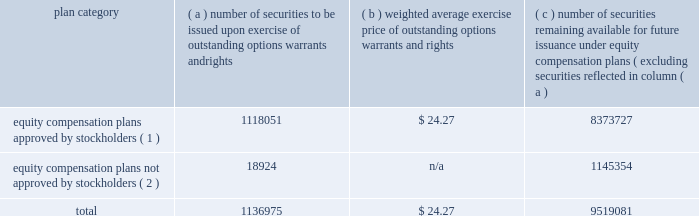Dividends and distributions we pay regular quarterly dividends to holders of our common stock .
On february 16 , 2007 , our board of directors declared the first quarterly installment of our 2007 dividend in the amount of $ 0.475 per share , payable on march 30 , 2007 to stockholders of record on march 20 , 2007 .
We expect to distribute 100% ( 100 % ) or more of our taxable net income to our stockholders for 2007 .
Our board of directors normally makes decisions regarding the frequency and amount of our dividends on a quarterly basis .
Because the board considers a number of factors when making these decisions , we cannot assure you that we will maintain the policy stated above .
Please see 201ccautionary statements 201d and the risk factors included in part i , item 1a of this annual report on form 10-k for a description of other factors that may affect our distribution policy .
Our stockholders may reinvest all or a portion of any cash distribution on their shares of our common stock by participating in our distribution reinvestment and stock purchase plan , subject to the terms of the plan .
See 201cnote 15 2014capital stock 201d of the notes to consolidated financial statements included in item 8 of this annual report on form 10-k .
Director and employee stock sales certain of our directors , executive officers and other employees have adopted and may , from time to time in the future , adopt non-discretionary , written trading plans that comply with rule 10b5-1 under the exchange act , or otherwise monetize their equity-based compensation .
Securities authorized for issuance under equity compensation plans the table summarizes information with respect to our equity compensation plans as of december 31 , 2006 : plan category number of securities to be issued upon exercise of outstanding options , warrants and rights weighted average exercise price of outstanding options , warrants and rights number of securities remaining available for future issuance under equity compensation plans ( excluding securities reflected in column ( a ) equity compensation plans approved by stockholders ( 1 ) .
1118051 $ 24.27 8373727 equity compensation plans not approved by stockholders ( 2 ) .
18924 n/a 1145354 .
( 1 ) these plans consist of ( i ) the 1987 incentive compensation program ( employee plan ) ; ( ii ) the theratx , incorporated 1996 stock option/stock issuance plan ; ( iii ) the 2000 incentive compensation plan ( employee plan ) ( formerly known as the 1997 incentive compensation plan ) ; ( iv ) the 2004 stock plan for directors ( which amended and restated the 2000 stock option plan for directors ( formerly known as the 1997 stock option plan for non-employee directors ) ) ; ( v ) the employee and director stock purchase plan ; ( vi ) the 2006 incentive plan ; and ( vii ) the 2006 stock plan for directors .
( 2 ) these plans consist of ( i ) the common stock purchase plan for directors , under which our non-employee directors may receive common stock in lieu of directors 2019 fees , ( ii ) the nonemployee director deferred stock compensation plan , under which our non-employee directors may receive units convertible on a one-for-one basis into common stock in lieu of director fees , and ( iii ) the executive deferred stock compensation plan , under which our executive officers may receive units convertible on a one-for-one basis into common stock in lieu of compensation. .
What is the total equity compensation plans approved by stockholders as of december 312006? 
Rationale: the total equity compensation plans approved by stockholders is the sum of the approved amount and remaining available for future issuance under equity compensation plans
Computations: (1118051 + 8373727)
Answer: 9491778.0. Dividends and distributions we pay regular quarterly dividends to holders of our common stock .
On february 16 , 2007 , our board of directors declared the first quarterly installment of our 2007 dividend in the amount of $ 0.475 per share , payable on march 30 , 2007 to stockholders of record on march 20 , 2007 .
We expect to distribute 100% ( 100 % ) or more of our taxable net income to our stockholders for 2007 .
Our board of directors normally makes decisions regarding the frequency and amount of our dividends on a quarterly basis .
Because the board considers a number of factors when making these decisions , we cannot assure you that we will maintain the policy stated above .
Please see 201ccautionary statements 201d and the risk factors included in part i , item 1a of this annual report on form 10-k for a description of other factors that may affect our distribution policy .
Our stockholders may reinvest all or a portion of any cash distribution on their shares of our common stock by participating in our distribution reinvestment and stock purchase plan , subject to the terms of the plan .
See 201cnote 15 2014capital stock 201d of the notes to consolidated financial statements included in item 8 of this annual report on form 10-k .
Director and employee stock sales certain of our directors , executive officers and other employees have adopted and may , from time to time in the future , adopt non-discretionary , written trading plans that comply with rule 10b5-1 under the exchange act , or otherwise monetize their equity-based compensation .
Securities authorized for issuance under equity compensation plans the table summarizes information with respect to our equity compensation plans as of december 31 , 2006 : plan category number of securities to be issued upon exercise of outstanding options , warrants and rights weighted average exercise price of outstanding options , warrants and rights number of securities remaining available for future issuance under equity compensation plans ( excluding securities reflected in column ( a ) equity compensation plans approved by stockholders ( 1 ) .
1118051 $ 24.27 8373727 equity compensation plans not approved by stockholders ( 2 ) .
18924 n/a 1145354 .
( 1 ) these plans consist of ( i ) the 1987 incentive compensation program ( employee plan ) ; ( ii ) the theratx , incorporated 1996 stock option/stock issuance plan ; ( iii ) the 2000 incentive compensation plan ( employee plan ) ( formerly known as the 1997 incentive compensation plan ) ; ( iv ) the 2004 stock plan for directors ( which amended and restated the 2000 stock option plan for directors ( formerly known as the 1997 stock option plan for non-employee directors ) ) ; ( v ) the employee and director stock purchase plan ; ( vi ) the 2006 incentive plan ; and ( vii ) the 2006 stock plan for directors .
( 2 ) these plans consist of ( i ) the common stock purchase plan for directors , under which our non-employee directors may receive common stock in lieu of directors 2019 fees , ( ii ) the nonemployee director deferred stock compensation plan , under which our non-employee directors may receive units convertible on a one-for-one basis into common stock in lieu of director fees , and ( iii ) the executive deferred stock compensation plan , under which our executive officers may receive units convertible on a one-for-one basis into common stock in lieu of compensation. .
What is the value of the equity compensation plans approved by stockholders to be issued upon exercise of outstanding options warrants and rights as of december 312006? 
Computations: (1118051 * 24.27)
Answer: 27135097.77. Dividends and distributions we pay regular quarterly dividends to holders of our common stock .
On february 16 , 2007 , our board of directors declared the first quarterly installment of our 2007 dividend in the amount of $ 0.475 per share , payable on march 30 , 2007 to stockholders of record on march 20 , 2007 .
We expect to distribute 100% ( 100 % ) or more of our taxable net income to our stockholders for 2007 .
Our board of directors normally makes decisions regarding the frequency and amount of our dividends on a quarterly basis .
Because the board considers a number of factors when making these decisions , we cannot assure you that we will maintain the policy stated above .
Please see 201ccautionary statements 201d and the risk factors included in part i , item 1a of this annual report on form 10-k for a description of other factors that may affect our distribution policy .
Our stockholders may reinvest all or a portion of any cash distribution on their shares of our common stock by participating in our distribution reinvestment and stock purchase plan , subject to the terms of the plan .
See 201cnote 15 2014capital stock 201d of the notes to consolidated financial statements included in item 8 of this annual report on form 10-k .
Director and employee stock sales certain of our directors , executive officers and other employees have adopted and may , from time to time in the future , adopt non-discretionary , written trading plans that comply with rule 10b5-1 under the exchange act , or otherwise monetize their equity-based compensation .
Securities authorized for issuance under equity compensation plans the table summarizes information with respect to our equity compensation plans as of december 31 , 2006 : plan category number of securities to be issued upon exercise of outstanding options , warrants and rights weighted average exercise price of outstanding options , warrants and rights number of securities remaining available for future issuance under equity compensation plans ( excluding securities reflected in column ( a ) equity compensation plans approved by stockholders ( 1 ) .
1118051 $ 24.27 8373727 equity compensation plans not approved by stockholders ( 2 ) .
18924 n/a 1145354 .
( 1 ) these plans consist of ( i ) the 1987 incentive compensation program ( employee plan ) ; ( ii ) the theratx , incorporated 1996 stock option/stock issuance plan ; ( iii ) the 2000 incentive compensation plan ( employee plan ) ( formerly known as the 1997 incentive compensation plan ) ; ( iv ) the 2004 stock plan for directors ( which amended and restated the 2000 stock option plan for directors ( formerly known as the 1997 stock option plan for non-employee directors ) ) ; ( v ) the employee and director stock purchase plan ; ( vi ) the 2006 incentive plan ; and ( vii ) the 2006 stock plan for directors .
( 2 ) these plans consist of ( i ) the common stock purchase plan for directors , under which our non-employee directors may receive common stock in lieu of directors 2019 fees , ( ii ) the nonemployee director deferred stock compensation plan , under which our non-employee directors may receive units convertible on a one-for-one basis into common stock in lieu of director fees , and ( iii ) the executive deferred stock compensation plan , under which our executive officers may receive units convertible on a one-for-one basis into common stock in lieu of compensation. .
What is the total cost of equity compensation plans approved by stockholders? 
Computations: (1118051 * 24.27)
Answer: 27135097.77. 